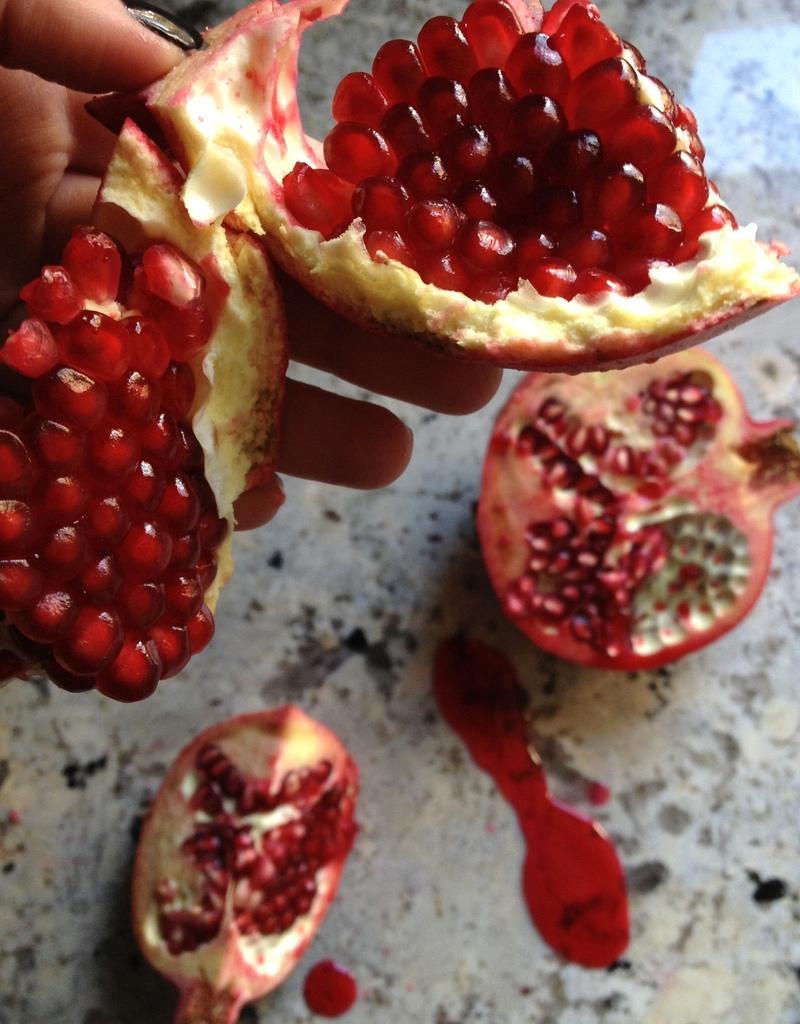In one or two sentences, can you explain what this image depicts? In this picture we can observe a pomegranate. Two pieces were placed on the floor. One piece was in the human hand. This fruit is in red color. 